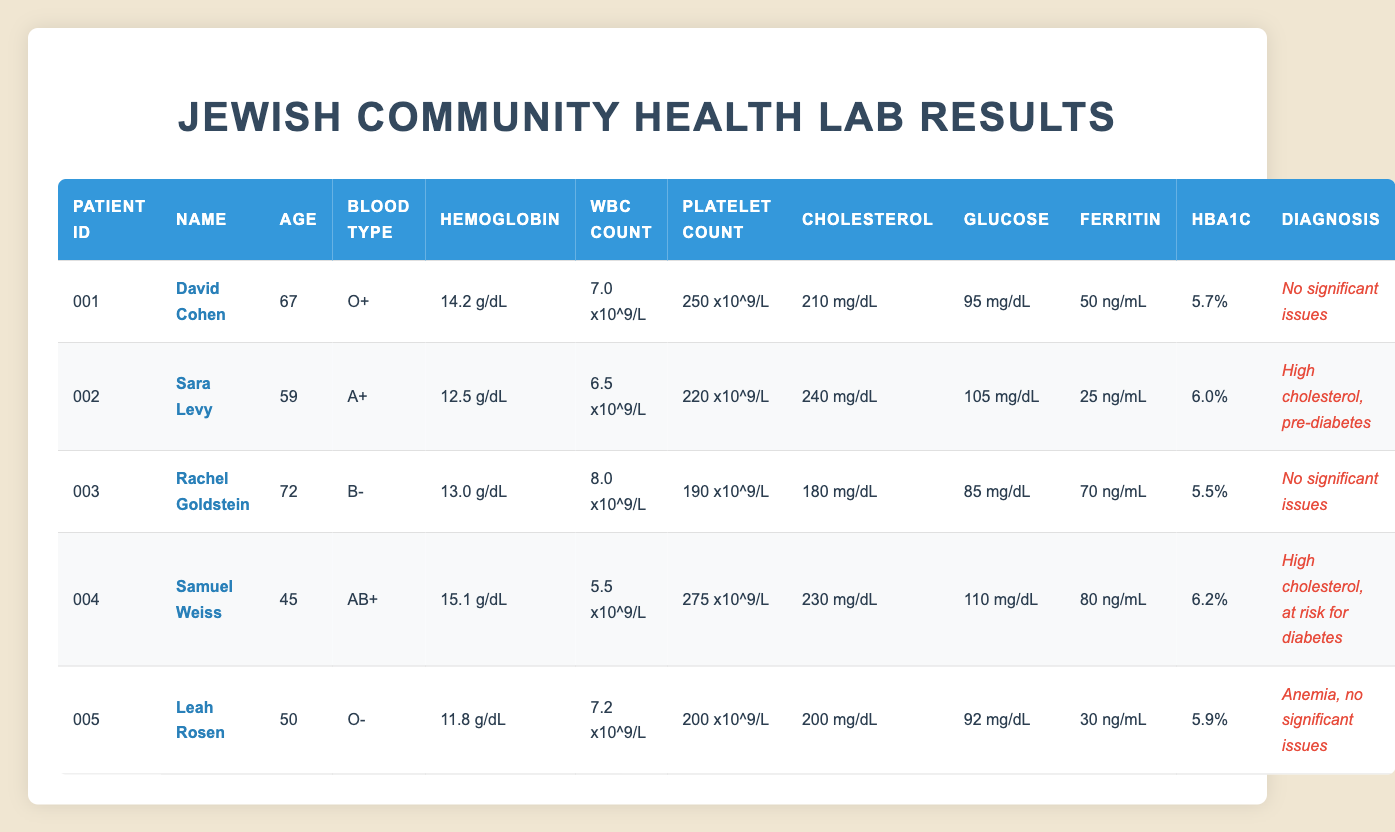What are the names of patients diagnosed with high cholesterol? From the table, we can see that both Sara Levy and Samuel Weiss have a diagnosis of high cholesterol. I can identify them by looking at the "Diagnosis" column for entries mentioning high cholesterol.
Answer: Sara Levy, Samuel Weiss What is the average age of patients in the table? To find the average, I first sum the ages: 67 + 59 + 72 + 45 + 50 = 293. Then, divide by the number of patients, which is 5. So, 293 / 5 = 58.6.
Answer: 58.6 Does David Cohen have any significant health issues? By checking the "Diagnosis" column for David Cohen, it states "No significant issues", which indicates he does not have any health problems reported.
Answer: No Which patient has the highest glucose level? Reviewing the "Glucose" column, I see that Samuel Weiss has the highest glucose level at 110 mg/dL, compared to the others.
Answer: Samuel Weiss What is the difference between the highest and lowest hemoglobin levels? The highest hemoglobin level is from Samuel Weiss at 15.1 g/dL and the lowest is from Leah Rosen at 11.8 g/dL. I calculate the difference: 15.1 - 11.8 = 3.3 g/dL.
Answer: 3.3 g/dL Is Leah Rosen's platelet count within the normal range? Leah Rosen’s platelet count is 200 x10^9/L. Normal platelet counts generally range from 150 to 450 x10^9/L, so I can confirm that her count is within this normal range.
Answer: Yes What is the cholesterol level of the patient with the lowest hemoglobin level? Leah Rosen has the lowest hemoglobin level at 11.8 g/dL, and by checking her cholesterol level in the "Cholesterol" column, it is 200 mg/dL.
Answer: 200 mg/dL How many patients are at risk for diabetes? Looking at the "Diagnosis" column, only Samuel Weiss is noted as being "at risk for diabetes", compared to others where no such risk is mentioned.
Answer: 1 What blood type does Rachel Goldstein have? I can refer directly to the "Blood Type" column for Rachel Goldstein, where it is specified that her blood type is B-.
Answer: B- 